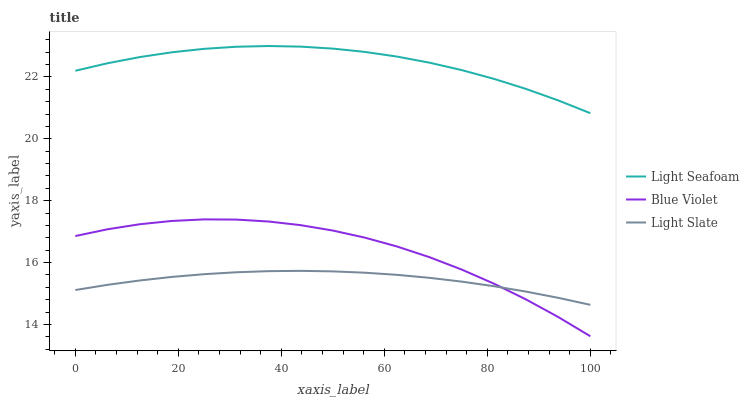Does Light Slate have the minimum area under the curve?
Answer yes or no. Yes. Does Light Seafoam have the maximum area under the curve?
Answer yes or no. Yes. Does Blue Violet have the minimum area under the curve?
Answer yes or no. No. Does Blue Violet have the maximum area under the curve?
Answer yes or no. No. Is Light Slate the smoothest?
Answer yes or no. Yes. Is Blue Violet the roughest?
Answer yes or no. Yes. Is Light Seafoam the smoothest?
Answer yes or no. No. Is Light Seafoam the roughest?
Answer yes or no. No. Does Blue Violet have the lowest value?
Answer yes or no. Yes. Does Light Seafoam have the lowest value?
Answer yes or no. No. Does Light Seafoam have the highest value?
Answer yes or no. Yes. Does Blue Violet have the highest value?
Answer yes or no. No. Is Light Slate less than Light Seafoam?
Answer yes or no. Yes. Is Light Seafoam greater than Blue Violet?
Answer yes or no. Yes. Does Light Slate intersect Blue Violet?
Answer yes or no. Yes. Is Light Slate less than Blue Violet?
Answer yes or no. No. Is Light Slate greater than Blue Violet?
Answer yes or no. No. Does Light Slate intersect Light Seafoam?
Answer yes or no. No. 